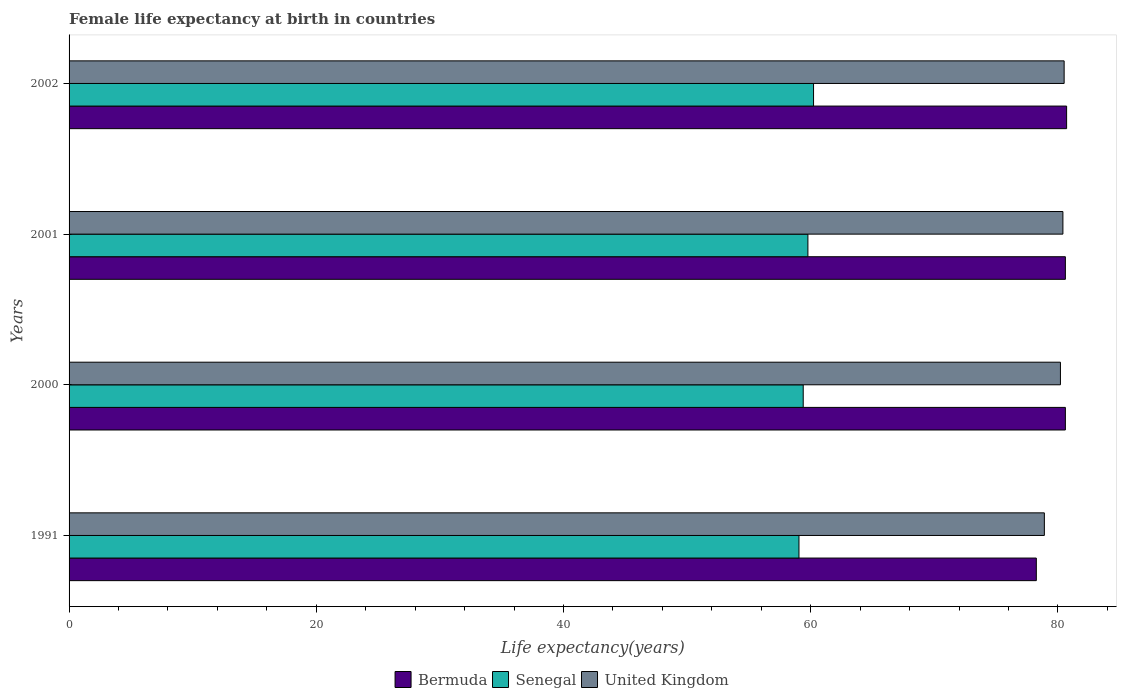How many different coloured bars are there?
Provide a succinct answer. 3. How many bars are there on the 3rd tick from the top?
Provide a succinct answer. 3. In how many cases, is the number of bars for a given year not equal to the number of legend labels?
Ensure brevity in your answer.  0. What is the female life expectancy at birth in Senegal in 2001?
Your answer should be very brief. 59.77. Across all years, what is the maximum female life expectancy at birth in United Kingdom?
Make the answer very short. 80.5. Across all years, what is the minimum female life expectancy at birth in Senegal?
Make the answer very short. 59.05. In which year was the female life expectancy at birth in United Kingdom minimum?
Ensure brevity in your answer.  1991. What is the total female life expectancy at birth in Senegal in the graph?
Your answer should be very brief. 238.44. What is the difference between the female life expectancy at birth in Bermuda in 1991 and that in 2000?
Offer a terse response. -2.35. What is the difference between the female life expectancy at birth in United Kingdom in 2000 and the female life expectancy at birth in Senegal in 1991?
Your response must be concise. 21.15. What is the average female life expectancy at birth in Senegal per year?
Make the answer very short. 59.61. In the year 1991, what is the difference between the female life expectancy at birth in Bermuda and female life expectancy at birth in Senegal?
Keep it short and to the point. 19.2. What is the ratio of the female life expectancy at birth in United Kingdom in 2000 to that in 2002?
Provide a succinct answer. 1. Is the female life expectancy at birth in Senegal in 2000 less than that in 2001?
Offer a very short reply. Yes. What is the difference between the highest and the second highest female life expectancy at birth in United Kingdom?
Your answer should be very brief. 0.1. What is the difference between the highest and the lowest female life expectancy at birth in United Kingdom?
Give a very brief answer. 1.6. What does the 2nd bar from the top in 1991 represents?
Your answer should be compact. Senegal. What does the 1st bar from the bottom in 2000 represents?
Offer a terse response. Bermuda. Are all the bars in the graph horizontal?
Offer a terse response. Yes. How many years are there in the graph?
Keep it short and to the point. 4. Does the graph contain any zero values?
Give a very brief answer. No. Does the graph contain grids?
Make the answer very short. No. How are the legend labels stacked?
Provide a succinct answer. Horizontal. What is the title of the graph?
Make the answer very short. Female life expectancy at birth in countries. Does "Macedonia" appear as one of the legend labels in the graph?
Offer a very short reply. No. What is the label or title of the X-axis?
Provide a short and direct response. Life expectancy(years). What is the label or title of the Y-axis?
Offer a very short reply. Years. What is the Life expectancy(years) of Bermuda in 1991?
Provide a short and direct response. 78.25. What is the Life expectancy(years) of Senegal in 1991?
Your answer should be compact. 59.05. What is the Life expectancy(years) in United Kingdom in 1991?
Make the answer very short. 78.9. What is the Life expectancy(years) of Bermuda in 2000?
Offer a very short reply. 80.6. What is the Life expectancy(years) of Senegal in 2000?
Ensure brevity in your answer.  59.39. What is the Life expectancy(years) of United Kingdom in 2000?
Ensure brevity in your answer.  80.2. What is the Life expectancy(years) in Bermuda in 2001?
Provide a succinct answer. 80.6. What is the Life expectancy(years) of Senegal in 2001?
Keep it short and to the point. 59.77. What is the Life expectancy(years) in United Kingdom in 2001?
Ensure brevity in your answer.  80.4. What is the Life expectancy(years) of Bermuda in 2002?
Your answer should be compact. 80.7. What is the Life expectancy(years) in Senegal in 2002?
Provide a succinct answer. 60.23. What is the Life expectancy(years) in United Kingdom in 2002?
Provide a short and direct response. 80.5. Across all years, what is the maximum Life expectancy(years) in Bermuda?
Your response must be concise. 80.7. Across all years, what is the maximum Life expectancy(years) in Senegal?
Ensure brevity in your answer.  60.23. Across all years, what is the maximum Life expectancy(years) in United Kingdom?
Your response must be concise. 80.5. Across all years, what is the minimum Life expectancy(years) of Bermuda?
Offer a terse response. 78.25. Across all years, what is the minimum Life expectancy(years) of Senegal?
Offer a very short reply. 59.05. Across all years, what is the minimum Life expectancy(years) of United Kingdom?
Offer a terse response. 78.9. What is the total Life expectancy(years) of Bermuda in the graph?
Make the answer very short. 320.15. What is the total Life expectancy(years) in Senegal in the graph?
Offer a very short reply. 238.44. What is the total Life expectancy(years) of United Kingdom in the graph?
Your answer should be compact. 320. What is the difference between the Life expectancy(years) of Bermuda in 1991 and that in 2000?
Offer a terse response. -2.35. What is the difference between the Life expectancy(years) of Senegal in 1991 and that in 2000?
Offer a very short reply. -0.34. What is the difference between the Life expectancy(years) of United Kingdom in 1991 and that in 2000?
Offer a terse response. -1.3. What is the difference between the Life expectancy(years) of Bermuda in 1991 and that in 2001?
Provide a short and direct response. -2.35. What is the difference between the Life expectancy(years) of Senegal in 1991 and that in 2001?
Offer a very short reply. -0.72. What is the difference between the Life expectancy(years) in United Kingdom in 1991 and that in 2001?
Keep it short and to the point. -1.5. What is the difference between the Life expectancy(years) of Bermuda in 1991 and that in 2002?
Provide a succinct answer. -2.45. What is the difference between the Life expectancy(years) in Senegal in 1991 and that in 2002?
Provide a short and direct response. -1.18. What is the difference between the Life expectancy(years) of Bermuda in 2000 and that in 2001?
Provide a short and direct response. 0. What is the difference between the Life expectancy(years) of Senegal in 2000 and that in 2001?
Provide a succinct answer. -0.38. What is the difference between the Life expectancy(years) of United Kingdom in 2000 and that in 2001?
Offer a very short reply. -0.2. What is the difference between the Life expectancy(years) of Senegal in 2000 and that in 2002?
Your answer should be compact. -0.84. What is the difference between the Life expectancy(years) in Senegal in 2001 and that in 2002?
Offer a very short reply. -0.46. What is the difference between the Life expectancy(years) in United Kingdom in 2001 and that in 2002?
Ensure brevity in your answer.  -0.1. What is the difference between the Life expectancy(years) in Bermuda in 1991 and the Life expectancy(years) in Senegal in 2000?
Your answer should be very brief. 18.86. What is the difference between the Life expectancy(years) in Bermuda in 1991 and the Life expectancy(years) in United Kingdom in 2000?
Provide a short and direct response. -1.95. What is the difference between the Life expectancy(years) of Senegal in 1991 and the Life expectancy(years) of United Kingdom in 2000?
Offer a very short reply. -21.15. What is the difference between the Life expectancy(years) of Bermuda in 1991 and the Life expectancy(years) of Senegal in 2001?
Keep it short and to the point. 18.48. What is the difference between the Life expectancy(years) of Bermuda in 1991 and the Life expectancy(years) of United Kingdom in 2001?
Offer a terse response. -2.15. What is the difference between the Life expectancy(years) of Senegal in 1991 and the Life expectancy(years) of United Kingdom in 2001?
Your answer should be very brief. -21.35. What is the difference between the Life expectancy(years) of Bermuda in 1991 and the Life expectancy(years) of Senegal in 2002?
Provide a short and direct response. 18.02. What is the difference between the Life expectancy(years) in Bermuda in 1991 and the Life expectancy(years) in United Kingdom in 2002?
Your answer should be very brief. -2.25. What is the difference between the Life expectancy(years) in Senegal in 1991 and the Life expectancy(years) in United Kingdom in 2002?
Give a very brief answer. -21.45. What is the difference between the Life expectancy(years) of Bermuda in 2000 and the Life expectancy(years) of Senegal in 2001?
Keep it short and to the point. 20.83. What is the difference between the Life expectancy(years) of Bermuda in 2000 and the Life expectancy(years) of United Kingdom in 2001?
Your response must be concise. 0.2. What is the difference between the Life expectancy(years) of Senegal in 2000 and the Life expectancy(years) of United Kingdom in 2001?
Ensure brevity in your answer.  -21.01. What is the difference between the Life expectancy(years) of Bermuda in 2000 and the Life expectancy(years) of Senegal in 2002?
Your response must be concise. 20.37. What is the difference between the Life expectancy(years) of Senegal in 2000 and the Life expectancy(years) of United Kingdom in 2002?
Your answer should be very brief. -21.11. What is the difference between the Life expectancy(years) of Bermuda in 2001 and the Life expectancy(years) of Senegal in 2002?
Provide a short and direct response. 20.37. What is the difference between the Life expectancy(years) of Bermuda in 2001 and the Life expectancy(years) of United Kingdom in 2002?
Offer a terse response. 0.1. What is the difference between the Life expectancy(years) in Senegal in 2001 and the Life expectancy(years) in United Kingdom in 2002?
Offer a terse response. -20.73. What is the average Life expectancy(years) in Bermuda per year?
Your answer should be compact. 80.04. What is the average Life expectancy(years) of Senegal per year?
Make the answer very short. 59.61. In the year 1991, what is the difference between the Life expectancy(years) of Bermuda and Life expectancy(years) of Senegal?
Your answer should be compact. 19.2. In the year 1991, what is the difference between the Life expectancy(years) in Bermuda and Life expectancy(years) in United Kingdom?
Provide a short and direct response. -0.65. In the year 1991, what is the difference between the Life expectancy(years) in Senegal and Life expectancy(years) in United Kingdom?
Offer a terse response. -19.85. In the year 2000, what is the difference between the Life expectancy(years) in Bermuda and Life expectancy(years) in Senegal?
Your answer should be very brief. 21.21. In the year 2000, what is the difference between the Life expectancy(years) in Bermuda and Life expectancy(years) in United Kingdom?
Provide a succinct answer. 0.4. In the year 2000, what is the difference between the Life expectancy(years) of Senegal and Life expectancy(years) of United Kingdom?
Offer a terse response. -20.81. In the year 2001, what is the difference between the Life expectancy(years) in Bermuda and Life expectancy(years) in Senegal?
Your answer should be compact. 20.83. In the year 2001, what is the difference between the Life expectancy(years) in Bermuda and Life expectancy(years) in United Kingdom?
Your answer should be very brief. 0.2. In the year 2001, what is the difference between the Life expectancy(years) in Senegal and Life expectancy(years) in United Kingdom?
Ensure brevity in your answer.  -20.63. In the year 2002, what is the difference between the Life expectancy(years) of Bermuda and Life expectancy(years) of Senegal?
Offer a very short reply. 20.47. In the year 2002, what is the difference between the Life expectancy(years) in Senegal and Life expectancy(years) in United Kingdom?
Provide a short and direct response. -20.27. What is the ratio of the Life expectancy(years) of Bermuda in 1991 to that in 2000?
Ensure brevity in your answer.  0.97. What is the ratio of the Life expectancy(years) of United Kingdom in 1991 to that in 2000?
Your response must be concise. 0.98. What is the ratio of the Life expectancy(years) of Bermuda in 1991 to that in 2001?
Your answer should be very brief. 0.97. What is the ratio of the Life expectancy(years) in Senegal in 1991 to that in 2001?
Provide a short and direct response. 0.99. What is the ratio of the Life expectancy(years) of United Kingdom in 1991 to that in 2001?
Your answer should be compact. 0.98. What is the ratio of the Life expectancy(years) in Bermuda in 1991 to that in 2002?
Give a very brief answer. 0.97. What is the ratio of the Life expectancy(years) in Senegal in 1991 to that in 2002?
Offer a terse response. 0.98. What is the ratio of the Life expectancy(years) of United Kingdom in 1991 to that in 2002?
Your answer should be compact. 0.98. What is the ratio of the Life expectancy(years) in Bermuda in 2000 to that in 2001?
Offer a terse response. 1. What is the ratio of the Life expectancy(years) in Senegal in 2000 to that in 2001?
Offer a very short reply. 0.99. What is the ratio of the Life expectancy(years) of United Kingdom in 2000 to that in 2001?
Make the answer very short. 1. What is the ratio of the Life expectancy(years) of Bermuda in 2000 to that in 2002?
Keep it short and to the point. 1. What is the ratio of the Life expectancy(years) in Senegal in 2000 to that in 2002?
Make the answer very short. 0.99. What is the ratio of the Life expectancy(years) in United Kingdom in 2000 to that in 2002?
Offer a terse response. 1. What is the ratio of the Life expectancy(years) in United Kingdom in 2001 to that in 2002?
Keep it short and to the point. 1. What is the difference between the highest and the second highest Life expectancy(years) in Senegal?
Provide a short and direct response. 0.46. What is the difference between the highest and the second highest Life expectancy(years) of United Kingdom?
Provide a short and direct response. 0.1. What is the difference between the highest and the lowest Life expectancy(years) of Bermuda?
Your answer should be very brief. 2.45. What is the difference between the highest and the lowest Life expectancy(years) in Senegal?
Give a very brief answer. 1.18. 